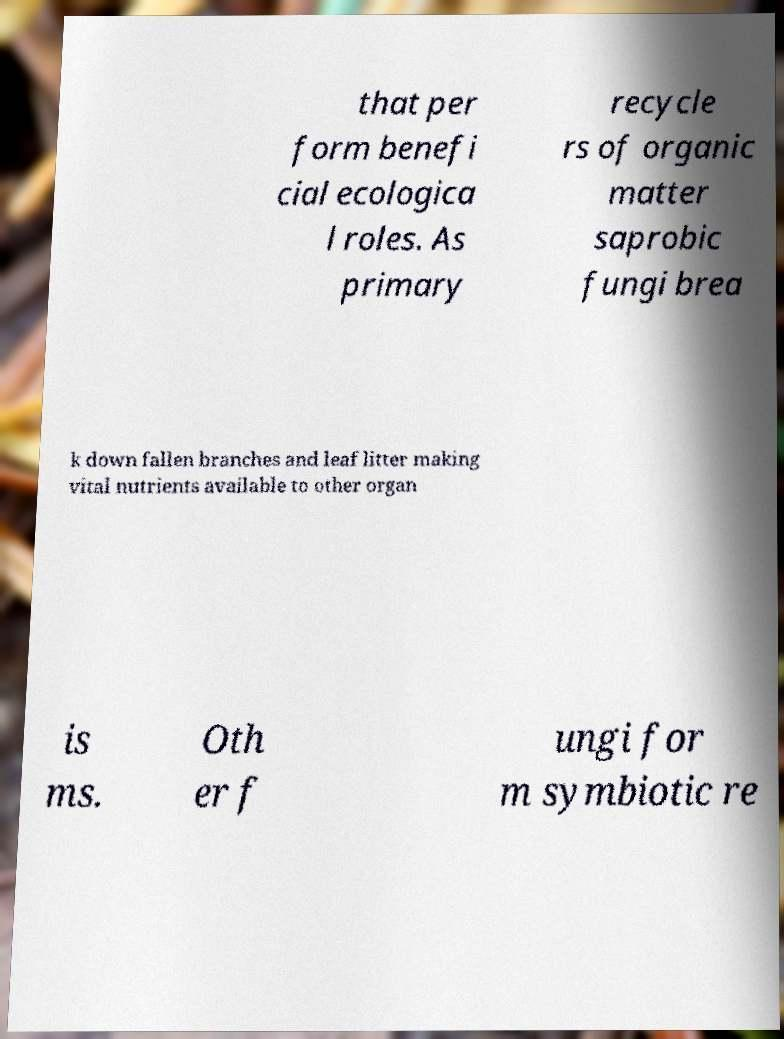There's text embedded in this image that I need extracted. Can you transcribe it verbatim? that per form benefi cial ecologica l roles. As primary recycle rs of organic matter saprobic fungi brea k down fallen branches and leaf litter making vital nutrients available to other organ is ms. Oth er f ungi for m symbiotic re 